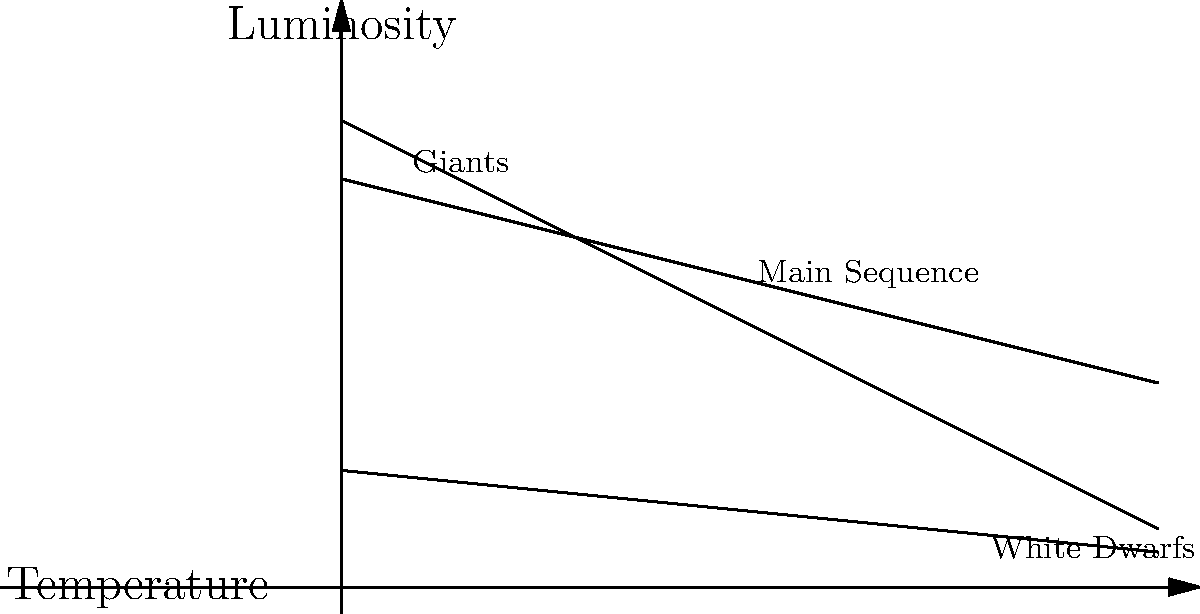Using the Hertzsprung-Russell diagram provided, explain the life cycle of a star like our Sun. Which stage will it reach after leaving the Main Sequence, and what will be its final stage? 1. The Hertzsprung-Russell diagram shows the relationship between a star's temperature and luminosity.

2. Our Sun is currently on the Main Sequence, where it spends most of its life fusing hydrogen into helium in its core.

3. When the Sun exhausts its core hydrogen:
   a) It will expand and cool, moving up and to the right on the diagram.
   b) This brings it to the Giants region, specifically becoming a Red Giant.

4. In the Red Giant phase:
   a) The Sun will fuse helium into heavier elements.
   b) Its outer layers will expand and eventually be shed.

5. After the Giant phase:
   a) The Sun lacks the mass to fuse elements heavier than carbon.
   b) It will lose its outer layers, exposing the hot core.

6. The final stage:
   a) The exposed core will cool and contract.
   b) This moves the star down and left on the diagram to the White Dwarf region.

7. As a White Dwarf:
   a) The Sun will no longer undergo fusion.
   b) It will slowly cool over billions of years, becoming dimmer and redder.
Answer: Giant stage, then White Dwarf 